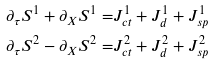Convert formula to latex. <formula><loc_0><loc_0><loc_500><loc_500>\partial _ { \tau } S ^ { 1 } + \partial _ { X } S ^ { 1 } = & J ^ { 1 } _ { c t } + J ^ { 1 } _ { d } + J ^ { 1 } _ { s p } \\ \partial _ { \tau } S ^ { 2 } - \partial _ { X } S ^ { 2 } = & J ^ { 2 } _ { c t } + J ^ { 2 } _ { d } + J ^ { 2 } _ { s p }</formula> 